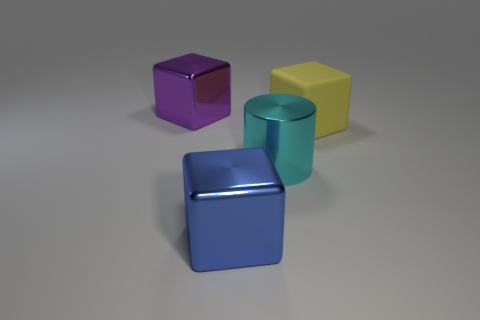There is a object that is to the left of the matte thing and behind the cyan thing; what size is it?
Offer a terse response. Large. There is a blue object that is the same shape as the purple metal thing; what material is it?
Keep it short and to the point. Metal. The cube right of the big thing that is in front of the big cyan metallic object is made of what material?
Your response must be concise. Rubber. Do the large rubber thing and the large object that is left of the blue metallic thing have the same shape?
Offer a very short reply. Yes. What number of matte things are large yellow blocks or big purple blocks?
Give a very brief answer. 1. What color is the large metal thing that is right of the large metallic cube in front of the large shiny cube that is behind the big blue object?
Offer a terse response. Cyan. How many other things are there of the same material as the big blue object?
Keep it short and to the point. 2. There is a thing that is behind the matte block; is its shape the same as the large yellow rubber object?
Your response must be concise. Yes. What number of small things are either matte things or cyan balls?
Your response must be concise. 0. Are there an equal number of shiny cylinders behind the big matte thing and blue metal objects that are to the right of the cylinder?
Your answer should be very brief. Yes. 